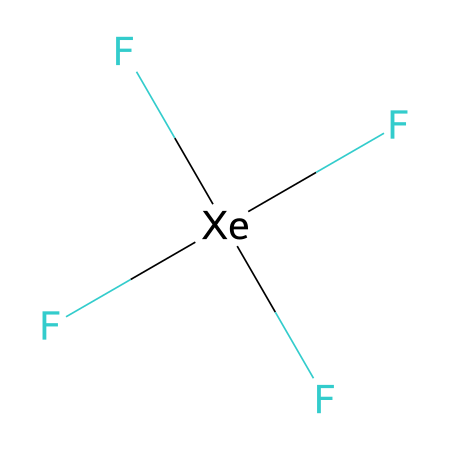What is the central atom in xenon tetrafluoride? The central atom in the structure represented by the SMILES notation is xenon (Xe), which is the atom surrounded by four fluorine (F) atoms.
Answer: xenon How many fluorine atoms are attached to the xenon atom? By analyzing the SMILES, there are four fluorine atoms indicated as they directly bond to the xenon atom. This can be seen by their presence in parentheses after the xenon atom.
Answer: four What is the total number of bonds in xenon tetrafluoride? The xenon atom is bonded to four fluorine atoms, which means there are four single bonds formed, resulting in a total of four bonds.
Answer: four What type of hybridization does xenon exhibit in this compound? In xenon tetrafluoride, the xenon atom must have sp³d hybridization, as it binds to five groups (one central atom and four attached fluorine atoms), requiring the involvement of d orbitals.
Answer: sp³d Why can xenon tetrafluoride be categorized as a hypervalent compound? Xenon tetrafluoride is categorized as hypervalent because the central xenon atom expands its valence shell to accommodate more than eight electrons by forming four covalent bonds with fluorine atoms, thus exceeding the octet rule.
Answer: hypervalent What geometry does xenon tetrafluoride exhibit? The molecular geometry for xenon tetrafluoride is square planar, determined by the arrangement of four fluorine atoms around the xenon atom while maintaining symmetry in the bonding structure.
Answer: square planar 